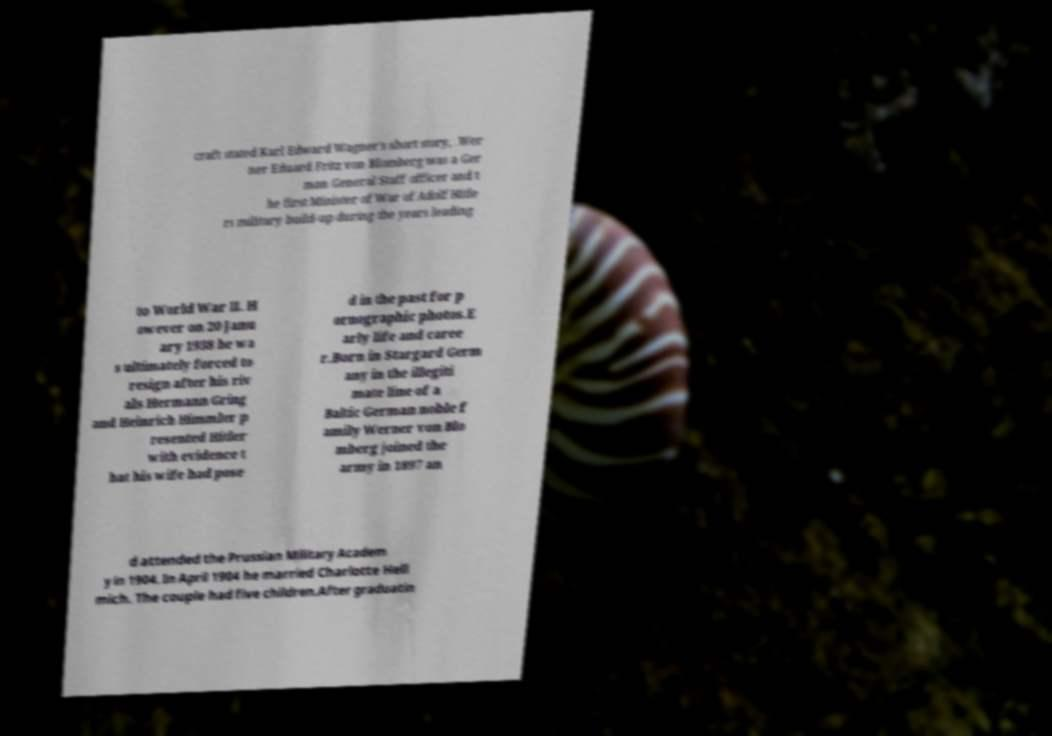Please identify and transcribe the text found in this image. craft stated Karl Edward Wagner's short story, .Wer ner Eduard Fritz von Blomberg was a Ger man General Staff officer and t he first Minister of War of Adolf Hitle rs military build-up during the years leading to World War II. H owever on 20 Janu ary 1938 he wa s ultimately forced to resign after his riv als Hermann Gring and Heinrich Himmler p resented Hitler with evidence t hat his wife had pose d in the past for p ornographic photos.E arly life and caree r.Born in Stargard Germ any in the illegiti mate line of a Baltic German noble f amily Werner von Blo mberg joined the army in 1897 an d attended the Prussian Military Academ y in 1904. In April 1904 he married Charlotte Hell mich. The couple had five children.After graduatin 